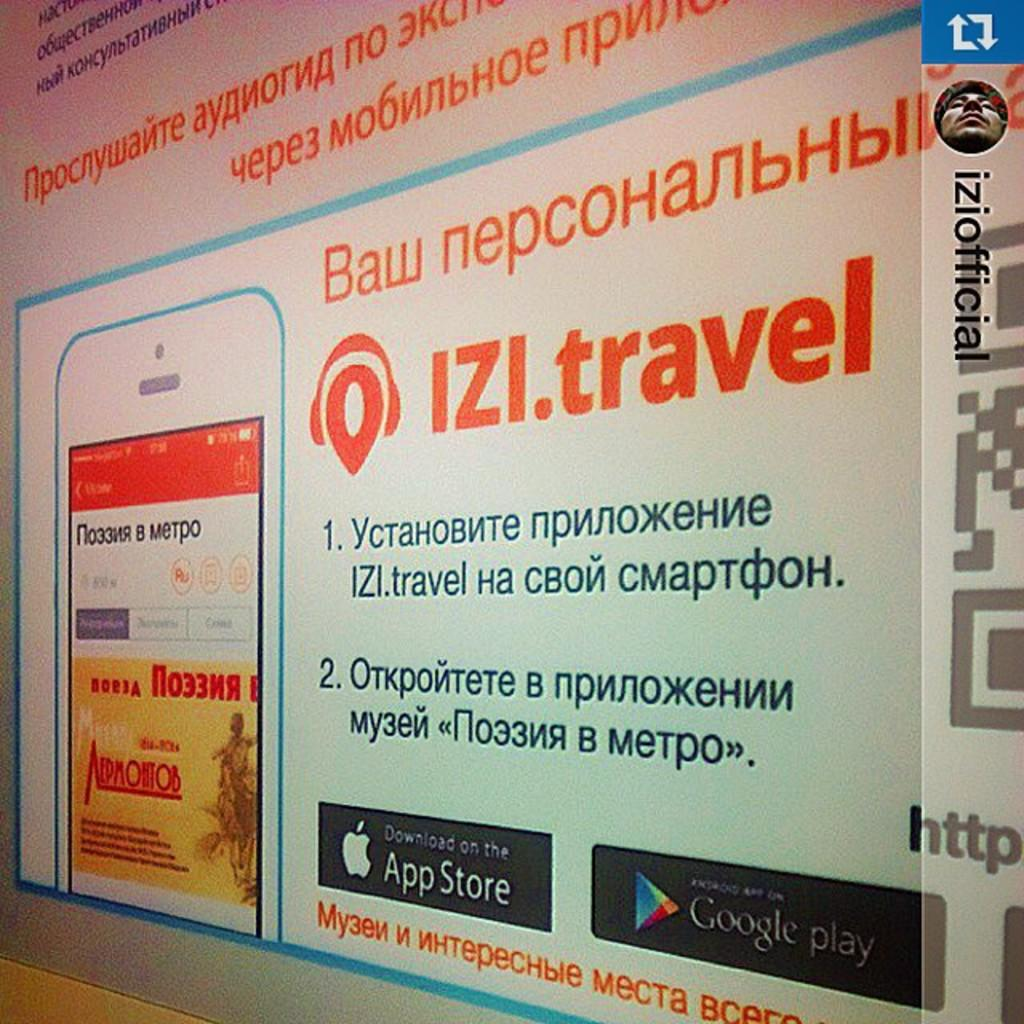What is the main subject of the image? There is an advertisement in the image. How many cats can be seen in the advertisement? There are no cats present in the image, as it only features an advertisement. 